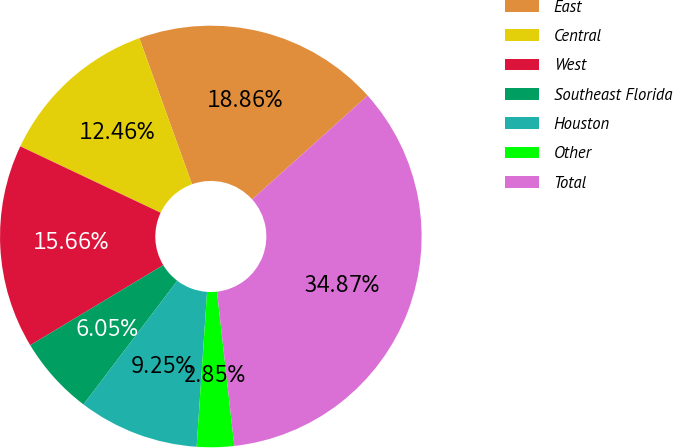Convert chart to OTSL. <chart><loc_0><loc_0><loc_500><loc_500><pie_chart><fcel>East<fcel>Central<fcel>West<fcel>Southeast Florida<fcel>Houston<fcel>Other<fcel>Total<nl><fcel>18.86%<fcel>12.46%<fcel>15.66%<fcel>6.05%<fcel>9.25%<fcel>2.85%<fcel>34.87%<nl></chart> 